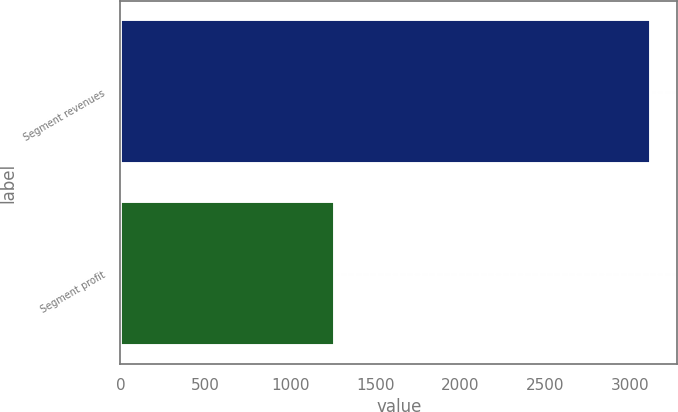Convert chart. <chart><loc_0><loc_0><loc_500><loc_500><bar_chart><fcel>Segment revenues<fcel>Segment profit<nl><fcel>3121<fcel>1260<nl></chart> 